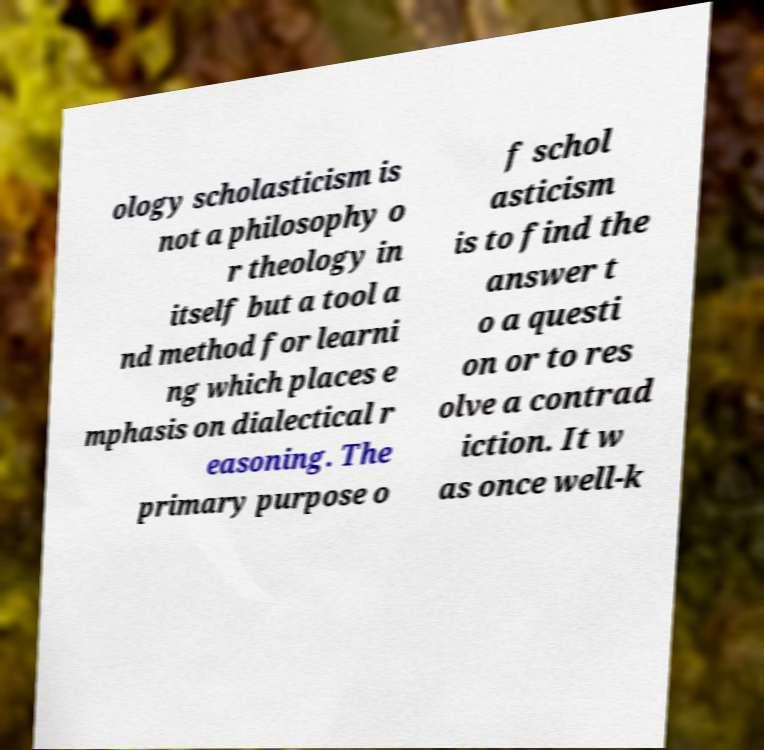I need the written content from this picture converted into text. Can you do that? ology scholasticism is not a philosophy o r theology in itself but a tool a nd method for learni ng which places e mphasis on dialectical r easoning. The primary purpose o f schol asticism is to find the answer t o a questi on or to res olve a contrad iction. It w as once well-k 